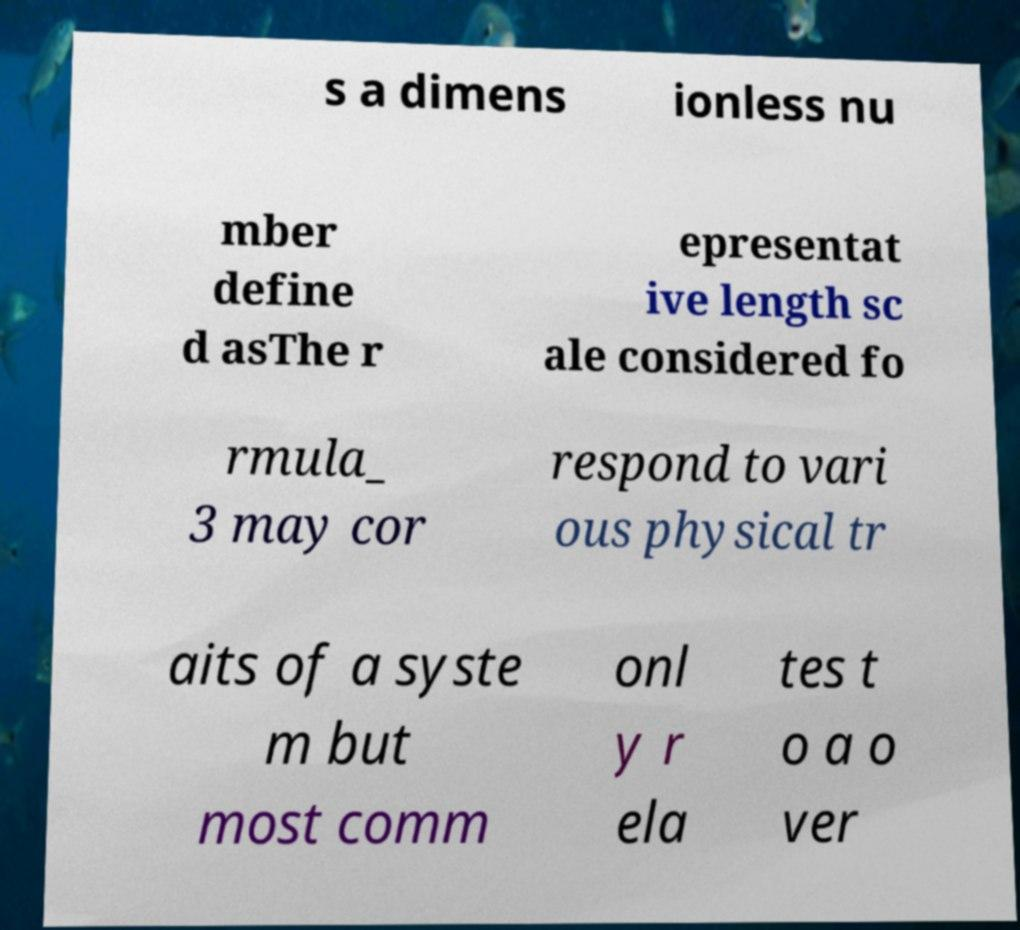For documentation purposes, I need the text within this image transcribed. Could you provide that? s a dimens ionless nu mber define d asThe r epresentat ive length sc ale considered fo rmula_ 3 may cor respond to vari ous physical tr aits of a syste m but most comm onl y r ela tes t o a o ver 